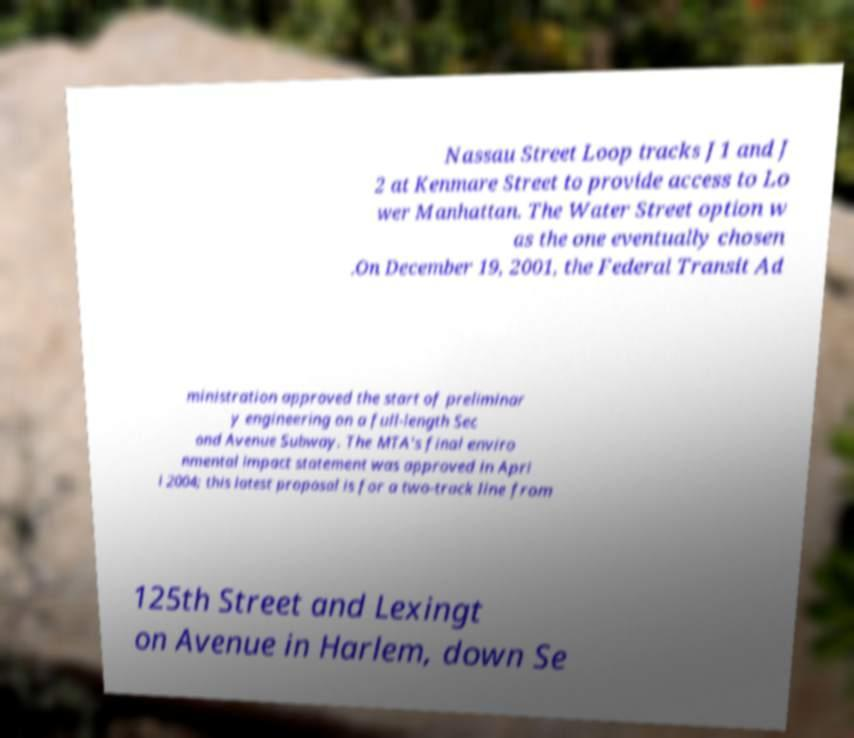I need the written content from this picture converted into text. Can you do that? Nassau Street Loop tracks J1 and J 2 at Kenmare Street to provide access to Lo wer Manhattan. The Water Street option w as the one eventually chosen .On December 19, 2001, the Federal Transit Ad ministration approved the start of preliminar y engineering on a full-length Sec ond Avenue Subway. The MTA's final enviro nmental impact statement was approved in Apri l 2004; this latest proposal is for a two-track line from 125th Street and Lexingt on Avenue in Harlem, down Se 